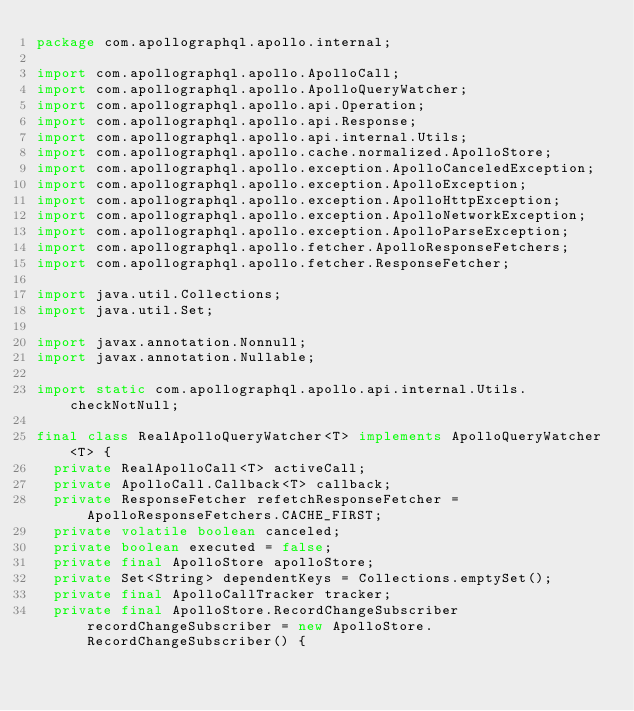Convert code to text. <code><loc_0><loc_0><loc_500><loc_500><_Java_>package com.apollographql.apollo.internal;

import com.apollographql.apollo.ApolloCall;
import com.apollographql.apollo.ApolloQueryWatcher;
import com.apollographql.apollo.api.Operation;
import com.apollographql.apollo.api.Response;
import com.apollographql.apollo.api.internal.Utils;
import com.apollographql.apollo.cache.normalized.ApolloStore;
import com.apollographql.apollo.exception.ApolloCanceledException;
import com.apollographql.apollo.exception.ApolloException;
import com.apollographql.apollo.exception.ApolloHttpException;
import com.apollographql.apollo.exception.ApolloNetworkException;
import com.apollographql.apollo.exception.ApolloParseException;
import com.apollographql.apollo.fetcher.ApolloResponseFetchers;
import com.apollographql.apollo.fetcher.ResponseFetcher;

import java.util.Collections;
import java.util.Set;

import javax.annotation.Nonnull;
import javax.annotation.Nullable;

import static com.apollographql.apollo.api.internal.Utils.checkNotNull;

final class RealApolloQueryWatcher<T> implements ApolloQueryWatcher<T> {
  private RealApolloCall<T> activeCall;
  private ApolloCall.Callback<T> callback;
  private ResponseFetcher refetchResponseFetcher = ApolloResponseFetchers.CACHE_FIRST;
  private volatile boolean canceled;
  private boolean executed = false;
  private final ApolloStore apolloStore;
  private Set<String> dependentKeys = Collections.emptySet();
  private final ApolloCallTracker tracker;
  private final ApolloStore.RecordChangeSubscriber recordChangeSubscriber = new ApolloStore.RecordChangeSubscriber() {</code> 